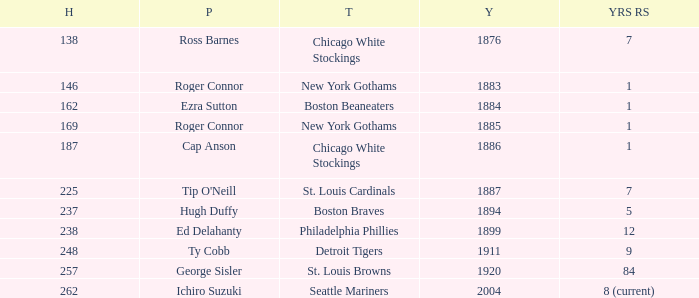Give me the full table as a dictionary. {'header': ['H', 'P', 'T', 'Y', 'YRS RS'], 'rows': [['138', 'Ross Barnes', 'Chicago White Stockings', '1876', '7'], ['146', 'Roger Connor', 'New York Gothams', '1883', '1'], ['162', 'Ezra Sutton', 'Boston Beaneaters', '1884', '1'], ['169', 'Roger Connor', 'New York Gothams', '1885', '1'], ['187', 'Cap Anson', 'Chicago White Stockings', '1886', '1'], ['225', "Tip O'Neill", 'St. Louis Cardinals', '1887', '7'], ['237', 'Hugh Duffy', 'Boston Braves', '1894', '5'], ['238', 'Ed Delahanty', 'Philadelphia Phillies', '1899', '12'], ['248', 'Ty Cobb', 'Detroit Tigers', '1911', '9'], ['257', 'George Sisler', 'St. Louis Browns', '1920', '84'], ['262', 'Ichiro Suzuki', 'Seattle Mariners', '2004', '8 (current)']]} Name the least hits for year less than 1920 and player of ed delahanty 238.0. 